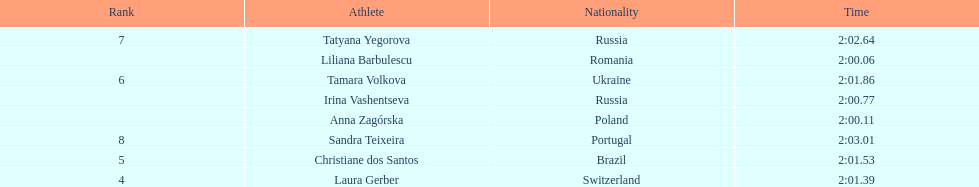The last runner crossed the finish line in 2:03.01. what was the previous time for the 7th runner? 2:02.64. Help me parse the entirety of this table. {'header': ['Rank', 'Athlete', 'Nationality', 'Time'], 'rows': [['7', 'Tatyana Yegorova', 'Russia', '2:02.64'], ['', 'Liliana Barbulescu', 'Romania', '2:00.06'], ['6', 'Tamara Volkova', 'Ukraine', '2:01.86'], ['', 'Irina Vashentseva', 'Russia', '2:00.77'], ['', 'Anna Zagórska', 'Poland', '2:00.11'], ['8', 'Sandra Teixeira', 'Portugal', '2:03.01'], ['5', 'Christiane dos Santos', 'Brazil', '2:01.53'], ['4', 'Laura Gerber', 'Switzerland', '2:01.39']]} 